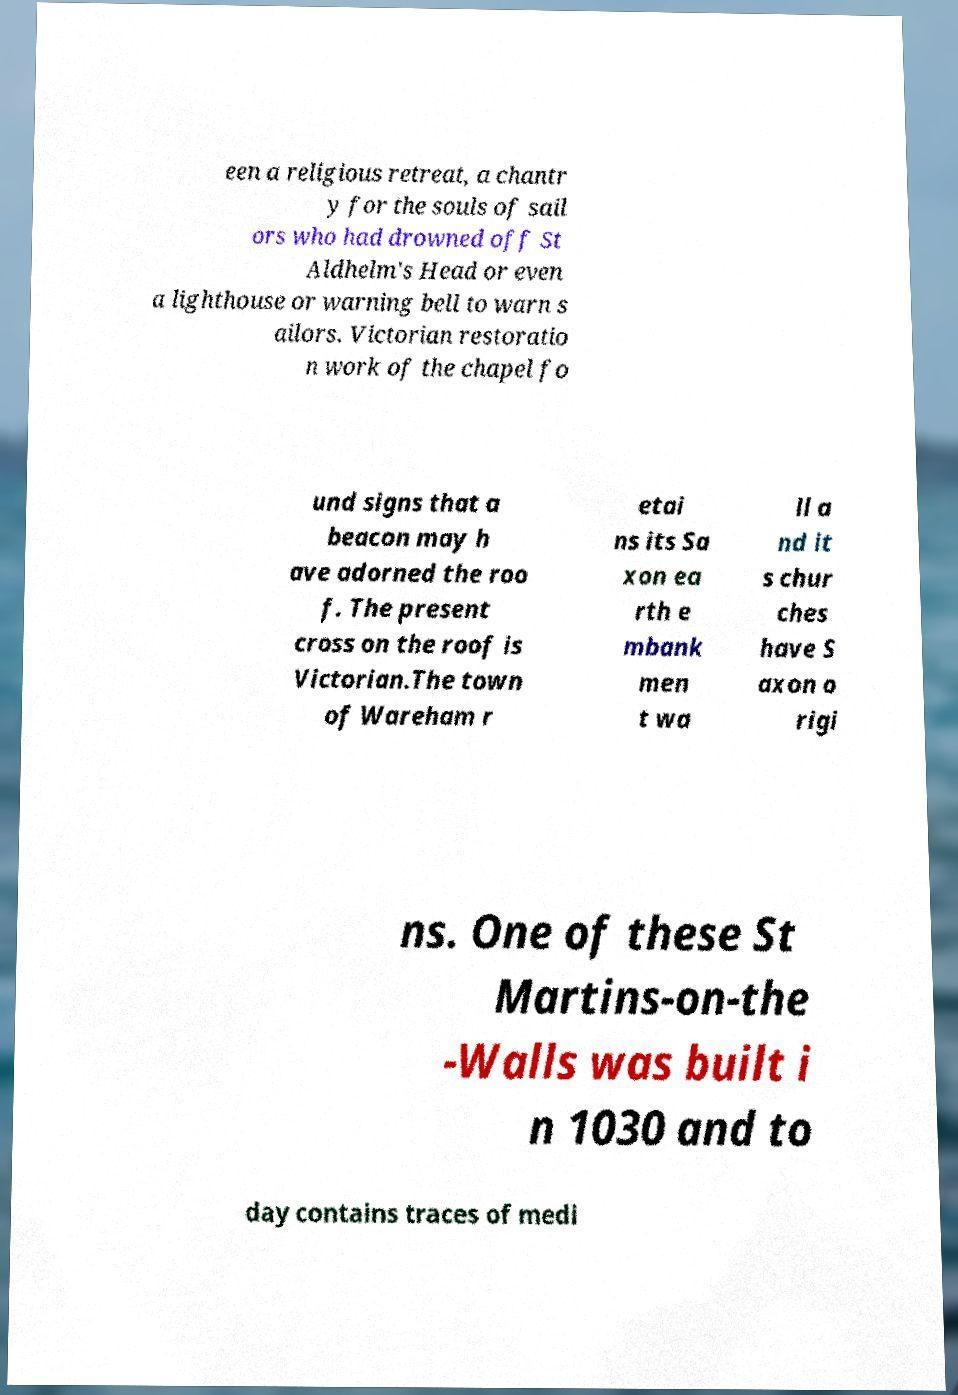What messages or text are displayed in this image? I need them in a readable, typed format. een a religious retreat, a chantr y for the souls of sail ors who had drowned off St Aldhelm's Head or even a lighthouse or warning bell to warn s ailors. Victorian restoratio n work of the chapel fo und signs that a beacon may h ave adorned the roo f. The present cross on the roof is Victorian.The town of Wareham r etai ns its Sa xon ea rth e mbank men t wa ll a nd it s chur ches have S axon o rigi ns. One of these St Martins-on-the -Walls was built i n 1030 and to day contains traces of medi 